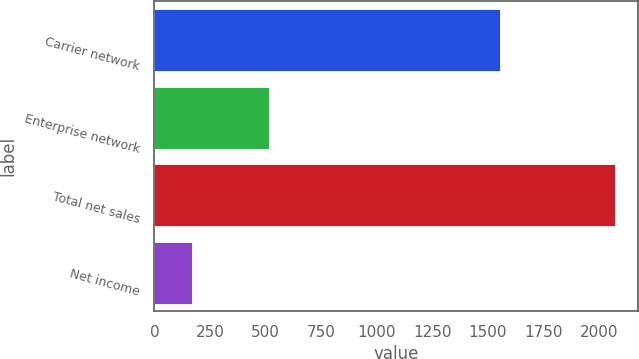Convert chart. <chart><loc_0><loc_0><loc_500><loc_500><bar_chart><fcel>Carrier network<fcel>Enterprise network<fcel>Total net sales<fcel>Net income<nl><fcel>1556<fcel>516<fcel>2072<fcel>168<nl></chart> 